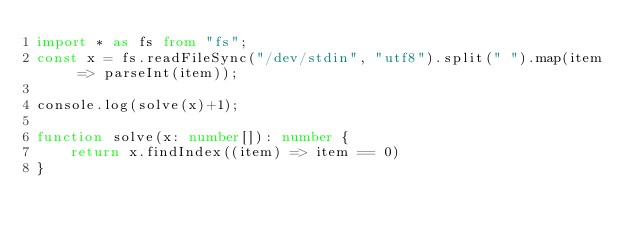<code> <loc_0><loc_0><loc_500><loc_500><_TypeScript_>import * as fs from "fs";
const x = fs.readFileSync("/dev/stdin", "utf8").split(" ").map(item => parseInt(item));

console.log(solve(x)+1);

function solve(x: number[]): number {
    return x.findIndex((item) => item == 0)
}</code> 